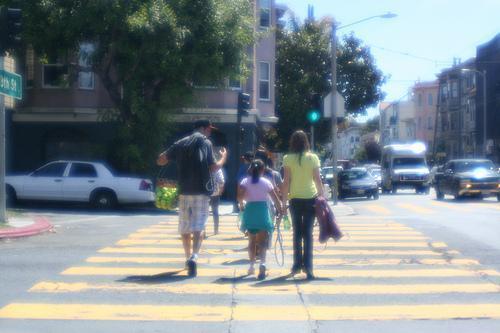How many people are there?
Give a very brief answer. 5. 